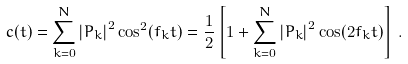Convert formula to latex. <formula><loc_0><loc_0><loc_500><loc_500>c ( t ) = \sum _ { k = 0 } ^ { N } \left | P _ { k } \right | ^ { 2 } \cos ^ { 2 } ( f _ { k } t ) = \frac { 1 } { 2 } \left [ 1 + \sum _ { k = 0 } ^ { N } \left | P _ { k } \right | ^ { 2 } \cos ( 2 f _ { k } t ) \right ] \, .</formula> 